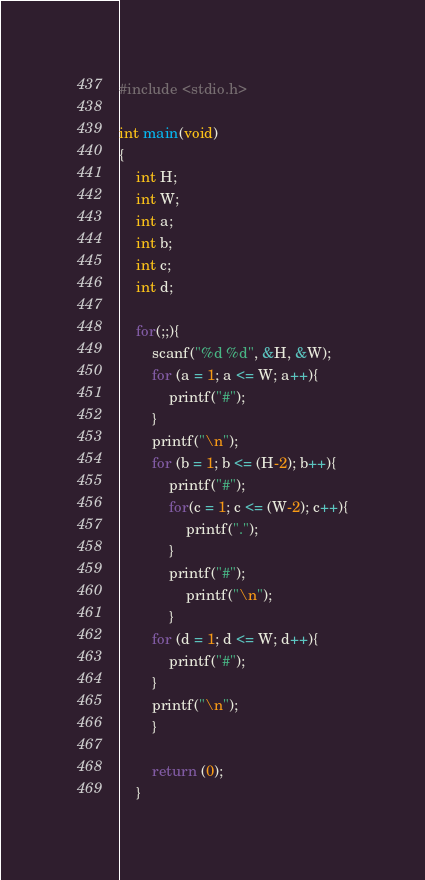Convert code to text. <code><loc_0><loc_0><loc_500><loc_500><_C_>#include <stdio.h>

int main(void)
{
	int H;
	int W;
	int a;
	int b;
	int c;
	int d;
	
	for(;;){
		scanf("%d %d", &H, &W);
		for (a = 1; a <= W; a++){
			printf("#");
		}
		printf("\n");
		for (b = 1; b <= (H-2); b++){
			printf("#");
			for(c = 1; c <= (W-2); c++){
				printf(".");
			}
			printf("#");
				printf("\n");
			}
		for (d = 1; d <= W; d++){
			printf("#");
		}
		printf("\n");
		}
		
		return (0);
	}</code> 